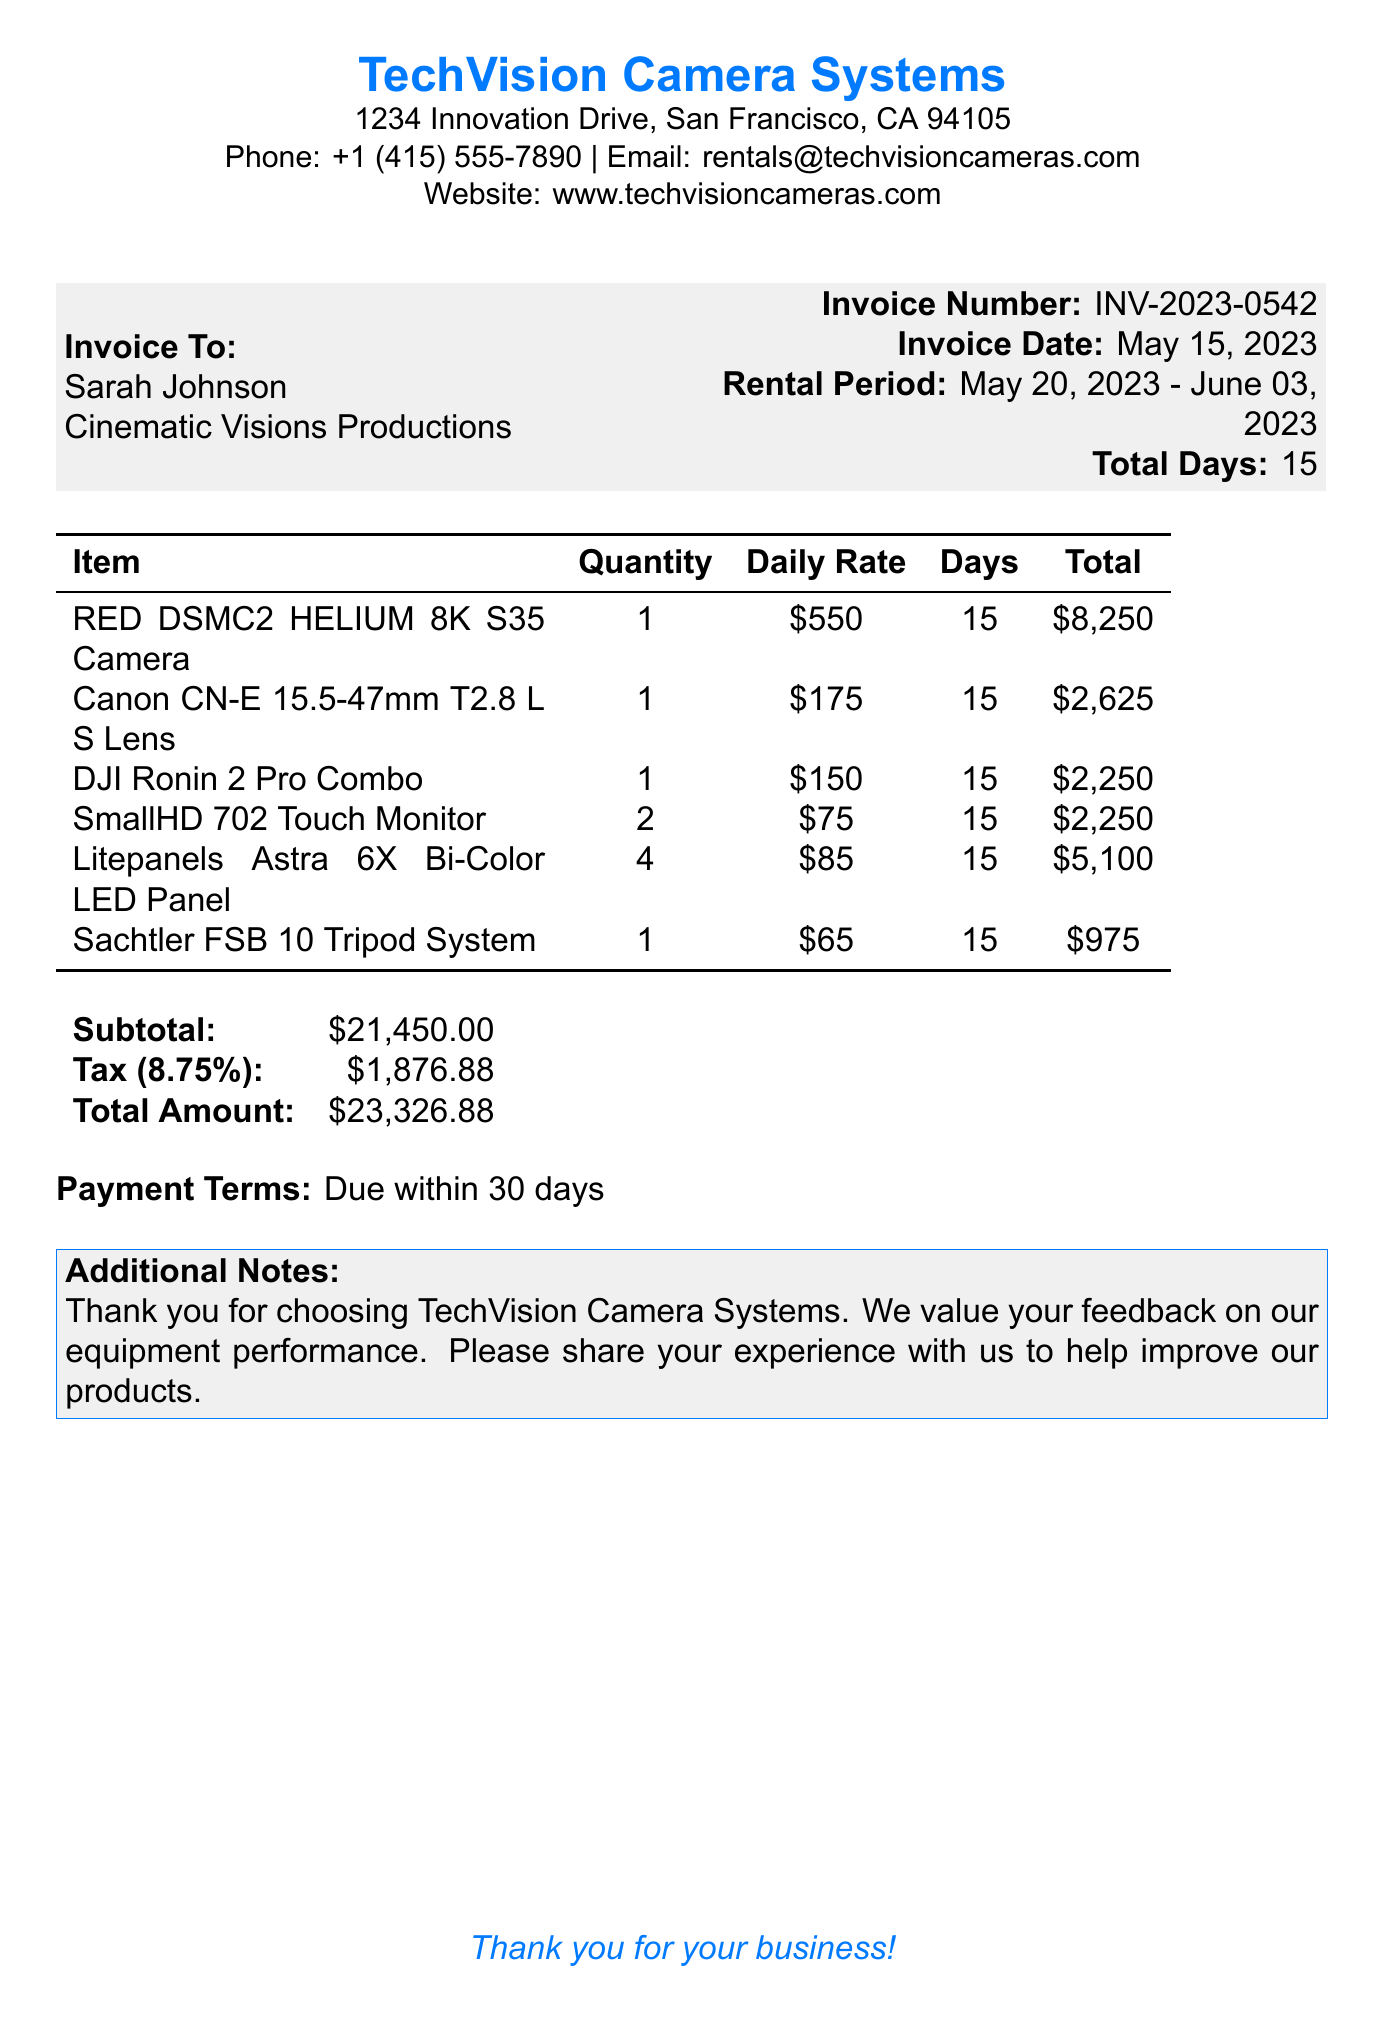what is the invoice number? The invoice number is stated prominently in the document as a unique identifier for the transaction.
Answer: INV-2023-0542 who is the customer? The document lists the name of the person or organization receiving the invoice.
Answer: Sarah Johnson what is the rental period? The rental period indicates the start and end dates of the equipment rental, which is critical for billing.
Answer: May 20, 2023 - June 03, 2023 how many days was the equipment rented? The total number of days the equipment was rented is specified in the rental period section.
Answer: 15 what is the daily rate for the RED DSMC2 HELIUM 8K S35 Camera? The daily rate is explicitly mentioned for each item being rented.
Answer: $550 what is the total amount due? The total amount due is the final figure resulting from the subtotal and tax calculations.
Answer: $23,326.88 how many SmallHD 702 Touch Monitors were rented? The quantity of each item rented is listed in the itemized list of the invoice.
Answer: 2 what is the tax rate applied to the invoice? The tax rate is clearly defined in the document, affecting the total amount due.
Answer: 8.75% what is the payment term for this invoice? Payment terms detail how long the customer has to pay the invoice before it is considered overdue.
Answer: Due within 30 days 